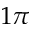Convert formula to latex. <formula><loc_0><loc_0><loc_500><loc_500>1 \pi</formula> 